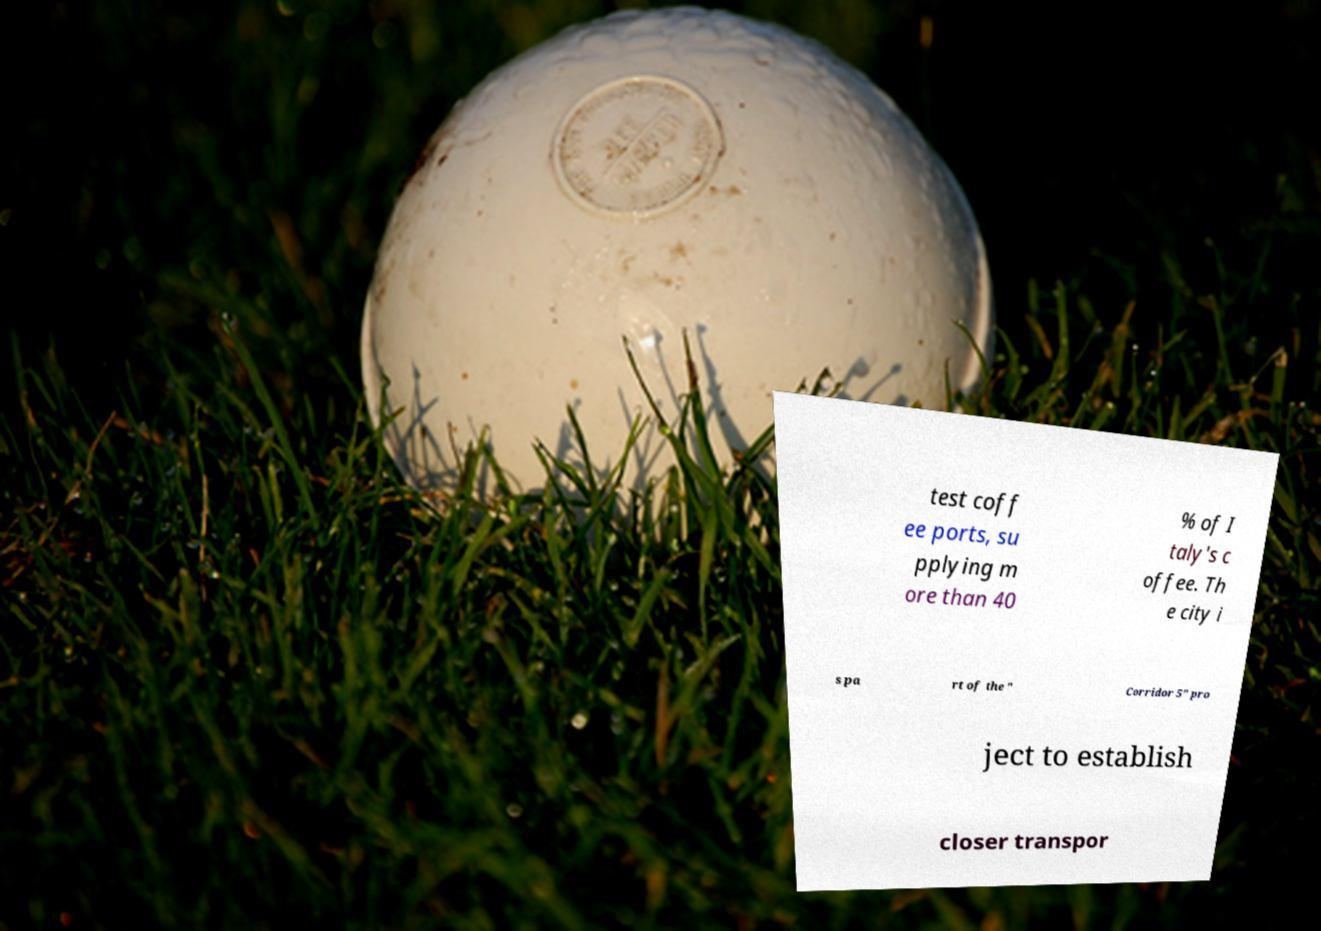Could you extract and type out the text from this image? test coff ee ports, su pplying m ore than 40 % of I taly's c offee. Th e city i s pa rt of the " Corridor 5" pro ject to establish closer transpor 